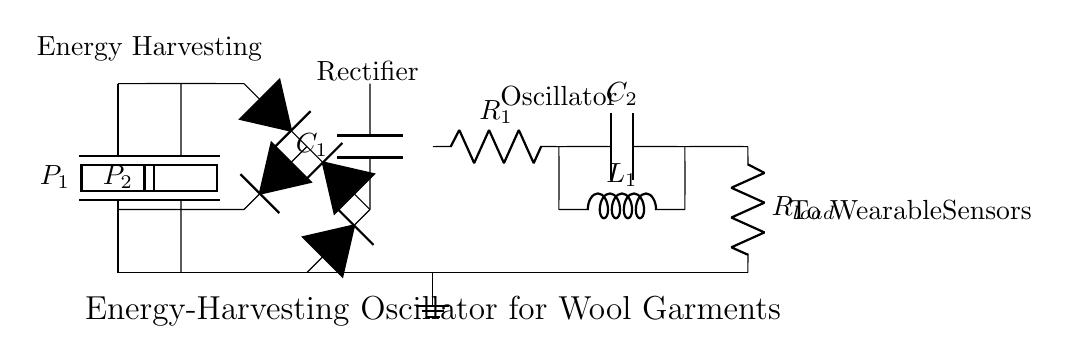what type of component is P1? P1 is a piezoelectric component, which is indicated in the circuit by its symbol and label. Piezoelectric components convert mechanical energy into electrical energy.
Answer: piezoelectric what is the role of the smoothing capacitor C1? The smoothing capacitor C1 is used to stabilize the output voltage by reducing voltage ripples after the rectification process. It smooths the DC output by storing and releasing charge.
Answer: stabilize how many piezoelectric components are connected in this circuit? There are two piezoelectric components marked as P1 and P2, which are responsible for energy harvesting from mechanical sources.
Answer: two what is the resistance value of R1 in the circuit? The resistance value is not specified in the circuit diagram, but R1 serves as part of the oscillator, controlling the charge and discharge cycle, which affects the oscillation frequency.
Answer: unspecified which part of the circuit is responsible for producing oscillations? The part responsible for producing oscillations is the combination of R1, C2, and L1, forming an RLC circuit that determines the frequency of the oscillations based on their values.
Answer: RLC circuit what happens to the energy harvested from the piezoelectric components? The energy harvested is converted to usable electrical energy by the rectifier and then oscillated through the RLC circuit before being supplied to the load, which are the wearable sensors.
Answer: provided to sensors what is the output of the oscillator connected to? The output of the oscillator is connected to a load resistor labeled R_load, which represents the wearable sensors receiving the oscillated energy.
Answer: wearable sensors 